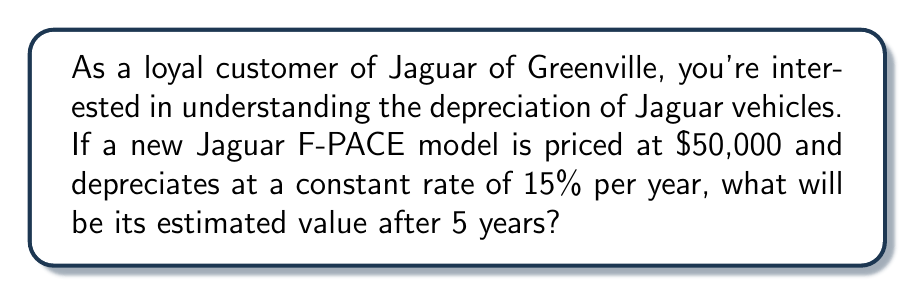What is the answer to this math problem? To solve this problem, we need to use the concept of exponential decay, as the vehicle's value decreases by a constant percentage each year.

Let's define our variables:
$P_0 = 50000$ (initial price)
$r = 0.15$ (depreciation rate)
$t = 5$ (time in years)

The formula for exponential decay is:

$$P(t) = P_0 \cdot (1-r)^t$$

Where $P(t)$ is the value after $t$ years.

Plugging in our values:

$$P(5) = 50000 \cdot (1-0.15)^5$$

Now, let's calculate step by step:

1) First, calculate $(1-0.15)^5$:
   $(1-0.15)^5 = 0.85^5 \approx 0.4437$

2) Multiply this by the initial price:
   $50000 \cdot 0.4437 \approx 22185$

Therefore, after 5 years, the estimated value of the Jaguar F-PACE will be approximately $22,185.
Answer: $22,185 